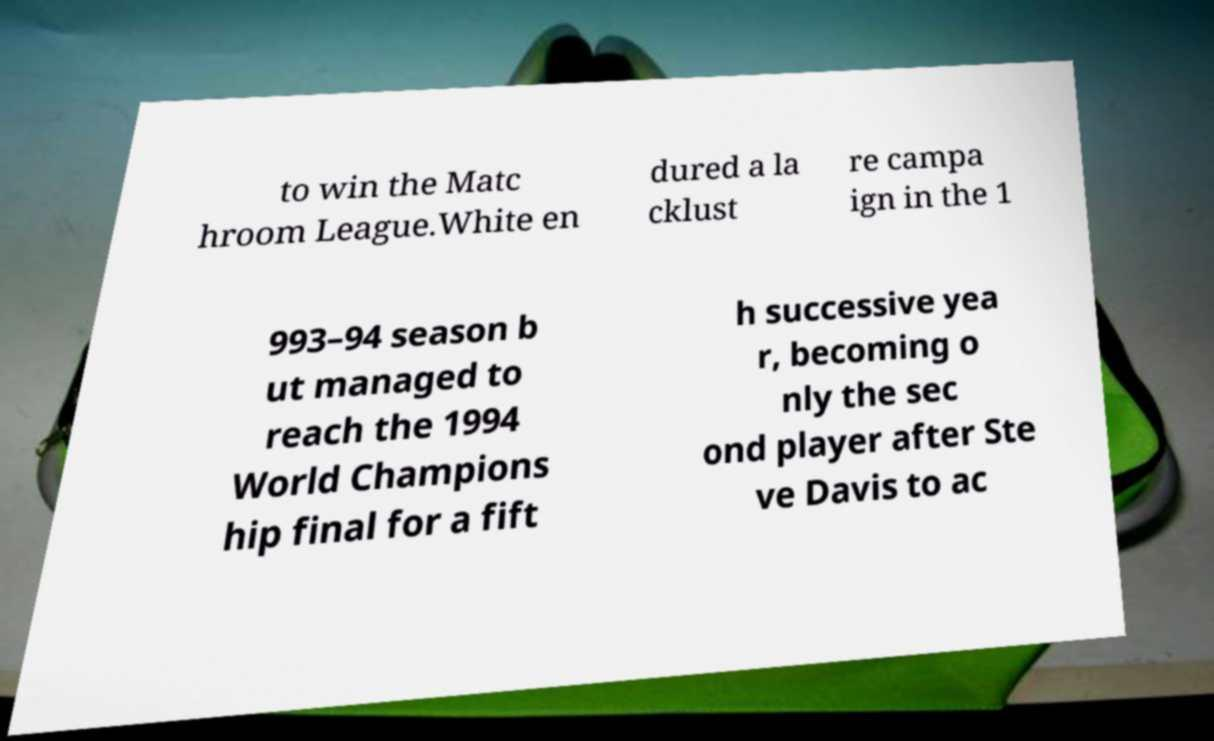Could you assist in decoding the text presented in this image and type it out clearly? to win the Matc hroom League.White en dured a la cklust re campa ign in the 1 993–94 season b ut managed to reach the 1994 World Champions hip final for a fift h successive yea r, becoming o nly the sec ond player after Ste ve Davis to ac 